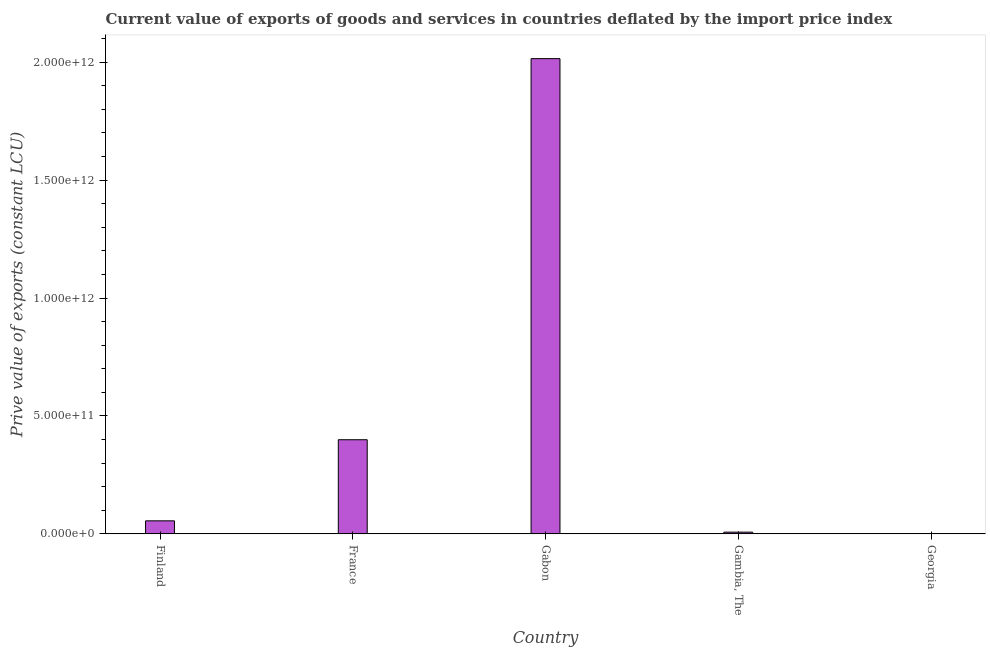Does the graph contain grids?
Make the answer very short. No. What is the title of the graph?
Keep it short and to the point. Current value of exports of goods and services in countries deflated by the import price index. What is the label or title of the Y-axis?
Provide a succinct answer. Prive value of exports (constant LCU). What is the price value of exports in Finland?
Offer a terse response. 5.52e+1. Across all countries, what is the maximum price value of exports?
Provide a succinct answer. 2.01e+12. Across all countries, what is the minimum price value of exports?
Make the answer very short. 8.64e+08. In which country was the price value of exports maximum?
Give a very brief answer. Gabon. In which country was the price value of exports minimum?
Ensure brevity in your answer.  Georgia. What is the sum of the price value of exports?
Provide a short and direct response. 2.48e+12. What is the difference between the price value of exports in Finland and France?
Give a very brief answer. -3.44e+11. What is the average price value of exports per country?
Make the answer very short. 4.95e+11. What is the median price value of exports?
Your answer should be very brief. 5.52e+1. What is the ratio of the price value of exports in Finland to that in Gambia, The?
Keep it short and to the point. 7.53. Is the difference between the price value of exports in Gambia, The and Georgia greater than the difference between any two countries?
Keep it short and to the point. No. What is the difference between the highest and the second highest price value of exports?
Keep it short and to the point. 1.62e+12. Is the sum of the price value of exports in France and Georgia greater than the maximum price value of exports across all countries?
Offer a terse response. No. What is the difference between the highest and the lowest price value of exports?
Offer a very short reply. 2.01e+12. How many bars are there?
Provide a succinct answer. 5. Are all the bars in the graph horizontal?
Provide a succinct answer. No. What is the difference between two consecutive major ticks on the Y-axis?
Give a very brief answer. 5.00e+11. Are the values on the major ticks of Y-axis written in scientific E-notation?
Your answer should be very brief. Yes. What is the Prive value of exports (constant LCU) in Finland?
Keep it short and to the point. 5.52e+1. What is the Prive value of exports (constant LCU) of France?
Make the answer very short. 3.99e+11. What is the Prive value of exports (constant LCU) of Gabon?
Make the answer very short. 2.01e+12. What is the Prive value of exports (constant LCU) in Gambia, The?
Provide a short and direct response. 7.33e+09. What is the Prive value of exports (constant LCU) in Georgia?
Make the answer very short. 8.64e+08. What is the difference between the Prive value of exports (constant LCU) in Finland and France?
Your answer should be very brief. -3.44e+11. What is the difference between the Prive value of exports (constant LCU) in Finland and Gabon?
Provide a short and direct response. -1.96e+12. What is the difference between the Prive value of exports (constant LCU) in Finland and Gambia, The?
Give a very brief answer. 4.79e+1. What is the difference between the Prive value of exports (constant LCU) in Finland and Georgia?
Your answer should be compact. 5.44e+1. What is the difference between the Prive value of exports (constant LCU) in France and Gabon?
Make the answer very short. -1.62e+12. What is the difference between the Prive value of exports (constant LCU) in France and Gambia, The?
Give a very brief answer. 3.92e+11. What is the difference between the Prive value of exports (constant LCU) in France and Georgia?
Provide a succinct answer. 3.98e+11. What is the difference between the Prive value of exports (constant LCU) in Gabon and Gambia, The?
Your response must be concise. 2.01e+12. What is the difference between the Prive value of exports (constant LCU) in Gabon and Georgia?
Your response must be concise. 2.01e+12. What is the difference between the Prive value of exports (constant LCU) in Gambia, The and Georgia?
Provide a short and direct response. 6.47e+09. What is the ratio of the Prive value of exports (constant LCU) in Finland to that in France?
Offer a very short reply. 0.14. What is the ratio of the Prive value of exports (constant LCU) in Finland to that in Gabon?
Provide a short and direct response. 0.03. What is the ratio of the Prive value of exports (constant LCU) in Finland to that in Gambia, The?
Offer a terse response. 7.53. What is the ratio of the Prive value of exports (constant LCU) in Finland to that in Georgia?
Keep it short and to the point. 63.91. What is the ratio of the Prive value of exports (constant LCU) in France to that in Gabon?
Offer a very short reply. 0.2. What is the ratio of the Prive value of exports (constant LCU) in France to that in Gambia, The?
Provide a short and direct response. 54.41. What is the ratio of the Prive value of exports (constant LCU) in France to that in Georgia?
Provide a short and direct response. 461.89. What is the ratio of the Prive value of exports (constant LCU) in Gabon to that in Gambia, The?
Give a very brief answer. 274.71. What is the ratio of the Prive value of exports (constant LCU) in Gabon to that in Georgia?
Ensure brevity in your answer.  2331.8. What is the ratio of the Prive value of exports (constant LCU) in Gambia, The to that in Georgia?
Make the answer very short. 8.49. 